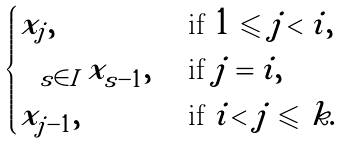<formula> <loc_0><loc_0><loc_500><loc_500>\begin{cases} x _ { j } , & \text { if } 1 \leqslant j < i , \\ \sum _ { s \in I } x _ { s - 1 } , & \text { if } j = i , \\ x _ { j - 1 } , & \text { if } i < j \leqslant k . \end{cases}</formula> 